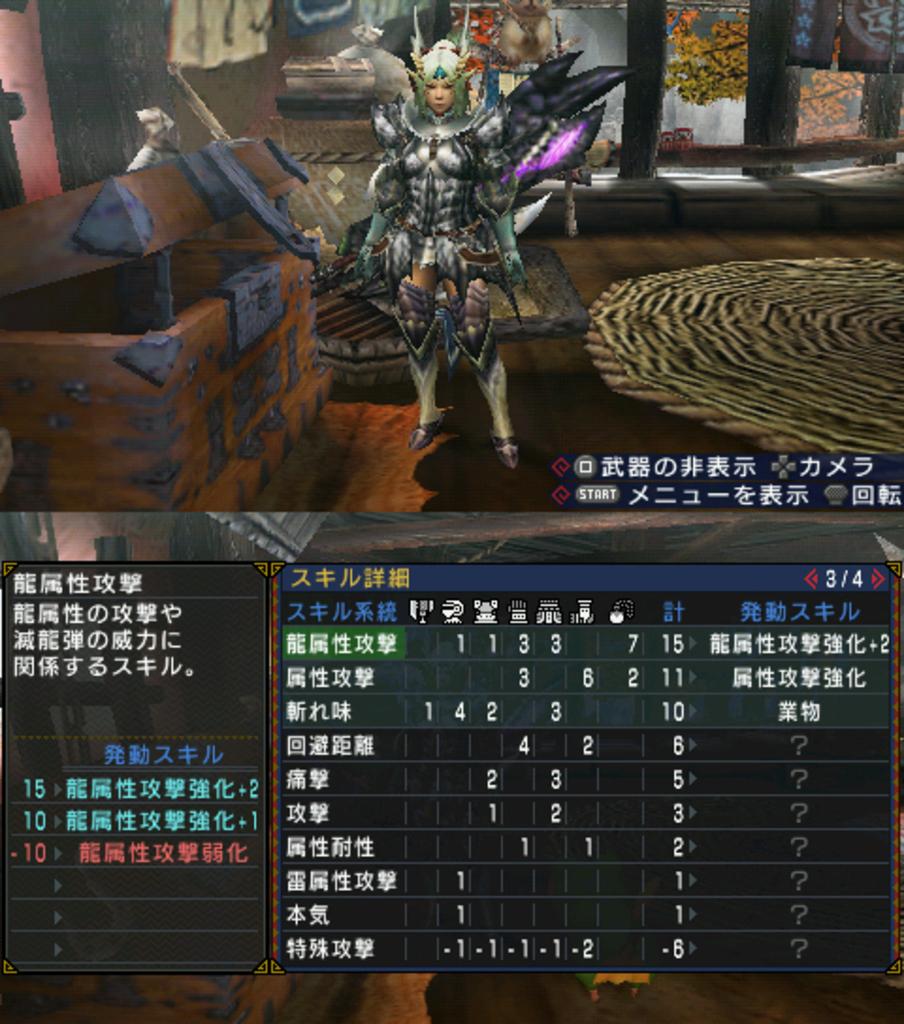What is the top most number?
Your answer should be very brief. 3/4. 